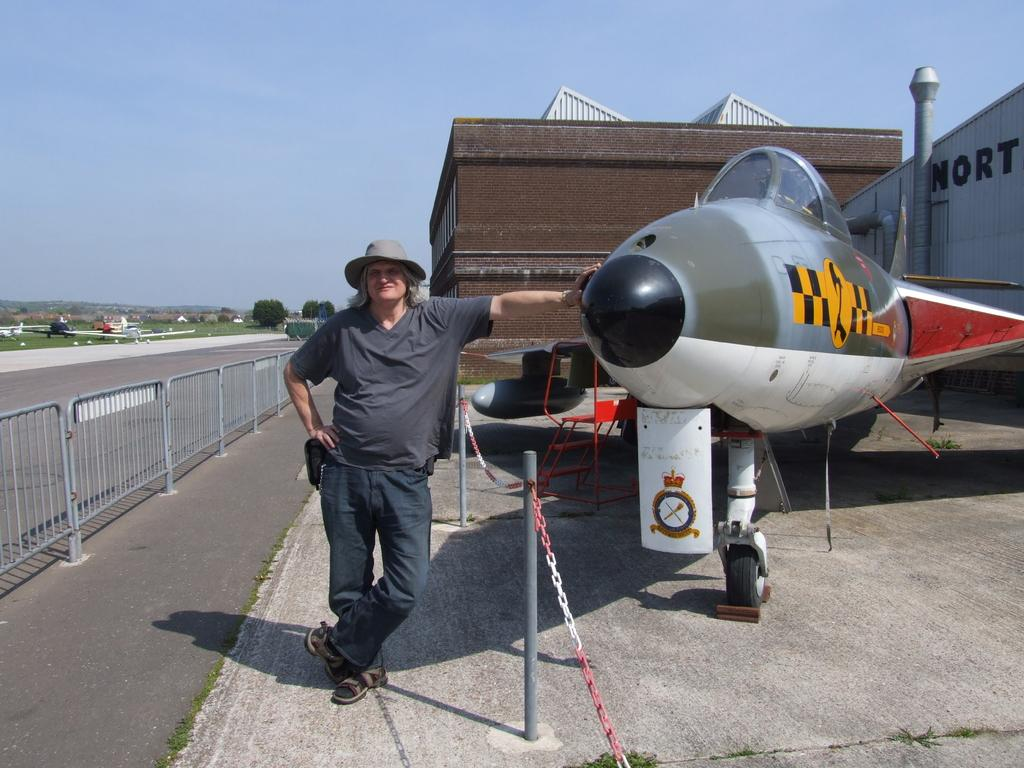<image>
Provide a brief description of the given image. a man and a plane are near one another beside a shipping container that says North 